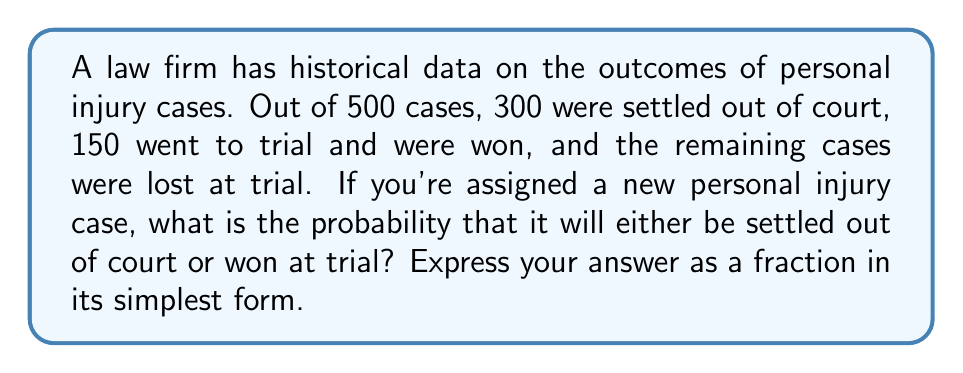Can you solve this math problem? Let's approach this step-by-step:

1) First, let's identify the key information:
   - Total cases: 500
   - Cases settled out of court: 300
   - Cases won at trial: 150
   - Remaining cases (lost at trial): 500 - 300 - 150 = 50

2) We need to find the probability of either settling out of court or winning at trial. In probability terms, this is the union of these two events.

3) To calculate this, we add the probabilities of each event:

   $P(\text{settled or won}) = P(\text{settled}) + P(\text{won})$

4) Calculate each probability:
   
   $P(\text{settled}) = \frac{300}{500} = \frac{3}{5}$
   
   $P(\text{won}) = \frac{150}{500} = \frac{3}{10}$

5) Add these probabilities:

   $P(\text{settled or won}) = \frac{3}{5} + \frac{3}{10} = \frac{6}{10} + \frac{3}{10} = \frac{9}{10}$

6) The fraction $\frac{9}{10}$ is already in its simplest form.
Answer: $\frac{9}{10}$ 